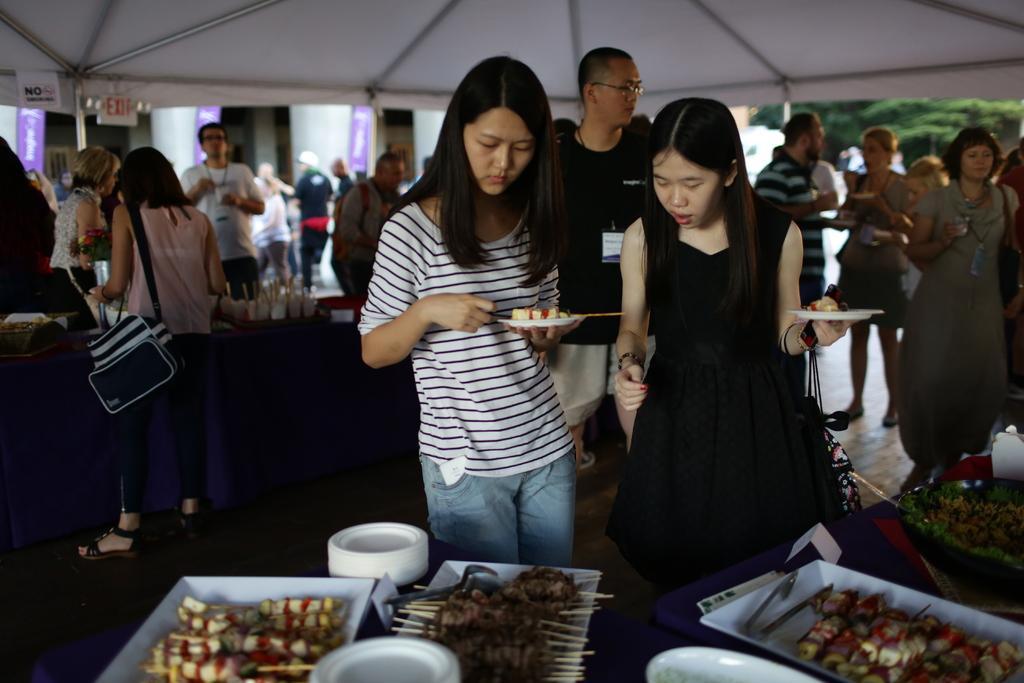Can you describe this image briefly? In this image under a tent there are many people having food. They are holding holding plates. In the foreground on a table there are many platters, plates. On the platter there are different kinds of food. In the background there are many people, building, trees. 